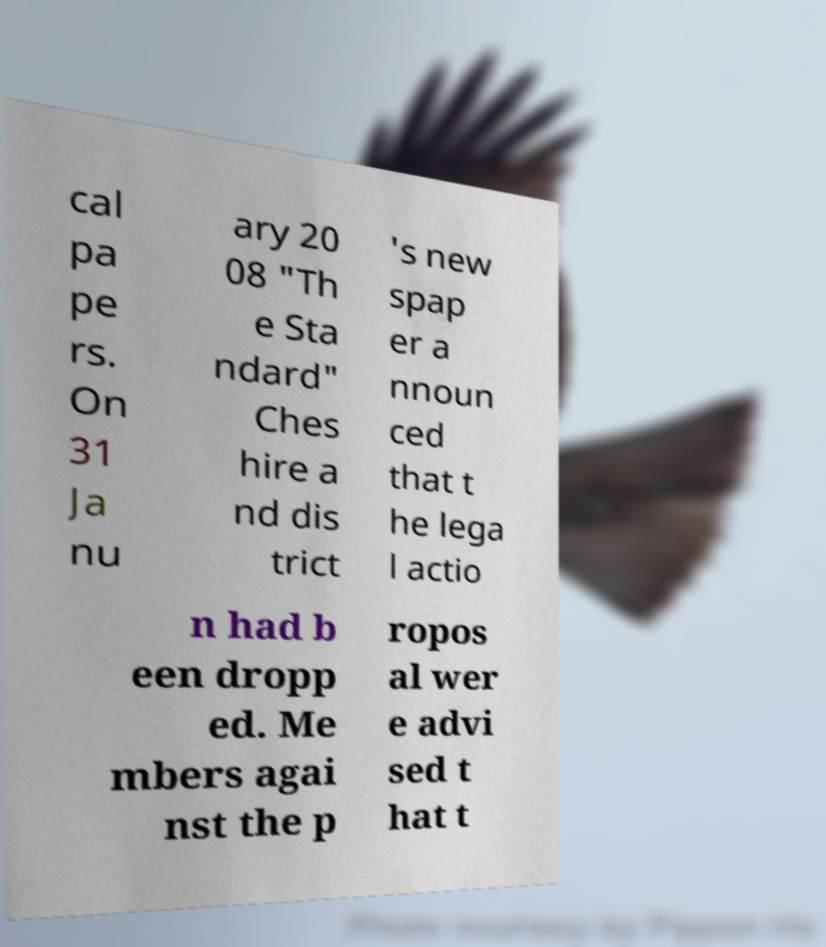Could you assist in decoding the text presented in this image and type it out clearly? cal pa pe rs. On 31 Ja nu ary 20 08 "Th e Sta ndard" Ches hire a nd dis trict 's new spap er a nnoun ced that t he lega l actio n had b een dropp ed. Me mbers agai nst the p ropos al wer e advi sed t hat t 